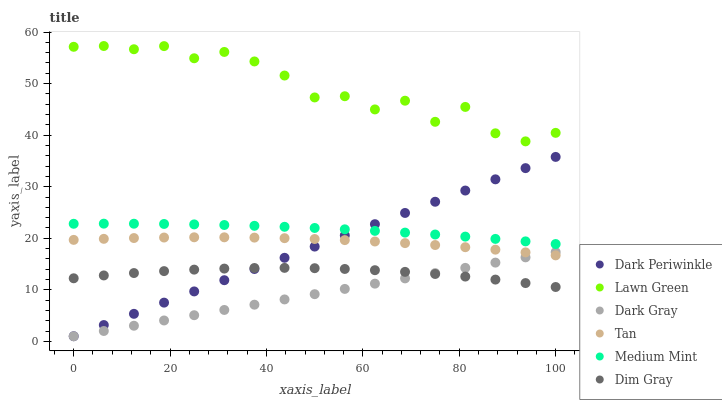Does Dark Gray have the minimum area under the curve?
Answer yes or no. Yes. Does Lawn Green have the maximum area under the curve?
Answer yes or no. Yes. Does Dim Gray have the minimum area under the curve?
Answer yes or no. No. Does Dim Gray have the maximum area under the curve?
Answer yes or no. No. Is Dark Periwinkle the smoothest?
Answer yes or no. Yes. Is Lawn Green the roughest?
Answer yes or no. Yes. Is Dim Gray the smoothest?
Answer yes or no. No. Is Dim Gray the roughest?
Answer yes or no. No. Does Dark Gray have the lowest value?
Answer yes or no. Yes. Does Dim Gray have the lowest value?
Answer yes or no. No. Does Lawn Green have the highest value?
Answer yes or no. Yes. Does Dim Gray have the highest value?
Answer yes or no. No. Is Dim Gray less than Medium Mint?
Answer yes or no. Yes. Is Medium Mint greater than Dark Gray?
Answer yes or no. Yes. Does Dark Periwinkle intersect Dark Gray?
Answer yes or no. Yes. Is Dark Periwinkle less than Dark Gray?
Answer yes or no. No. Is Dark Periwinkle greater than Dark Gray?
Answer yes or no. No. Does Dim Gray intersect Medium Mint?
Answer yes or no. No. 